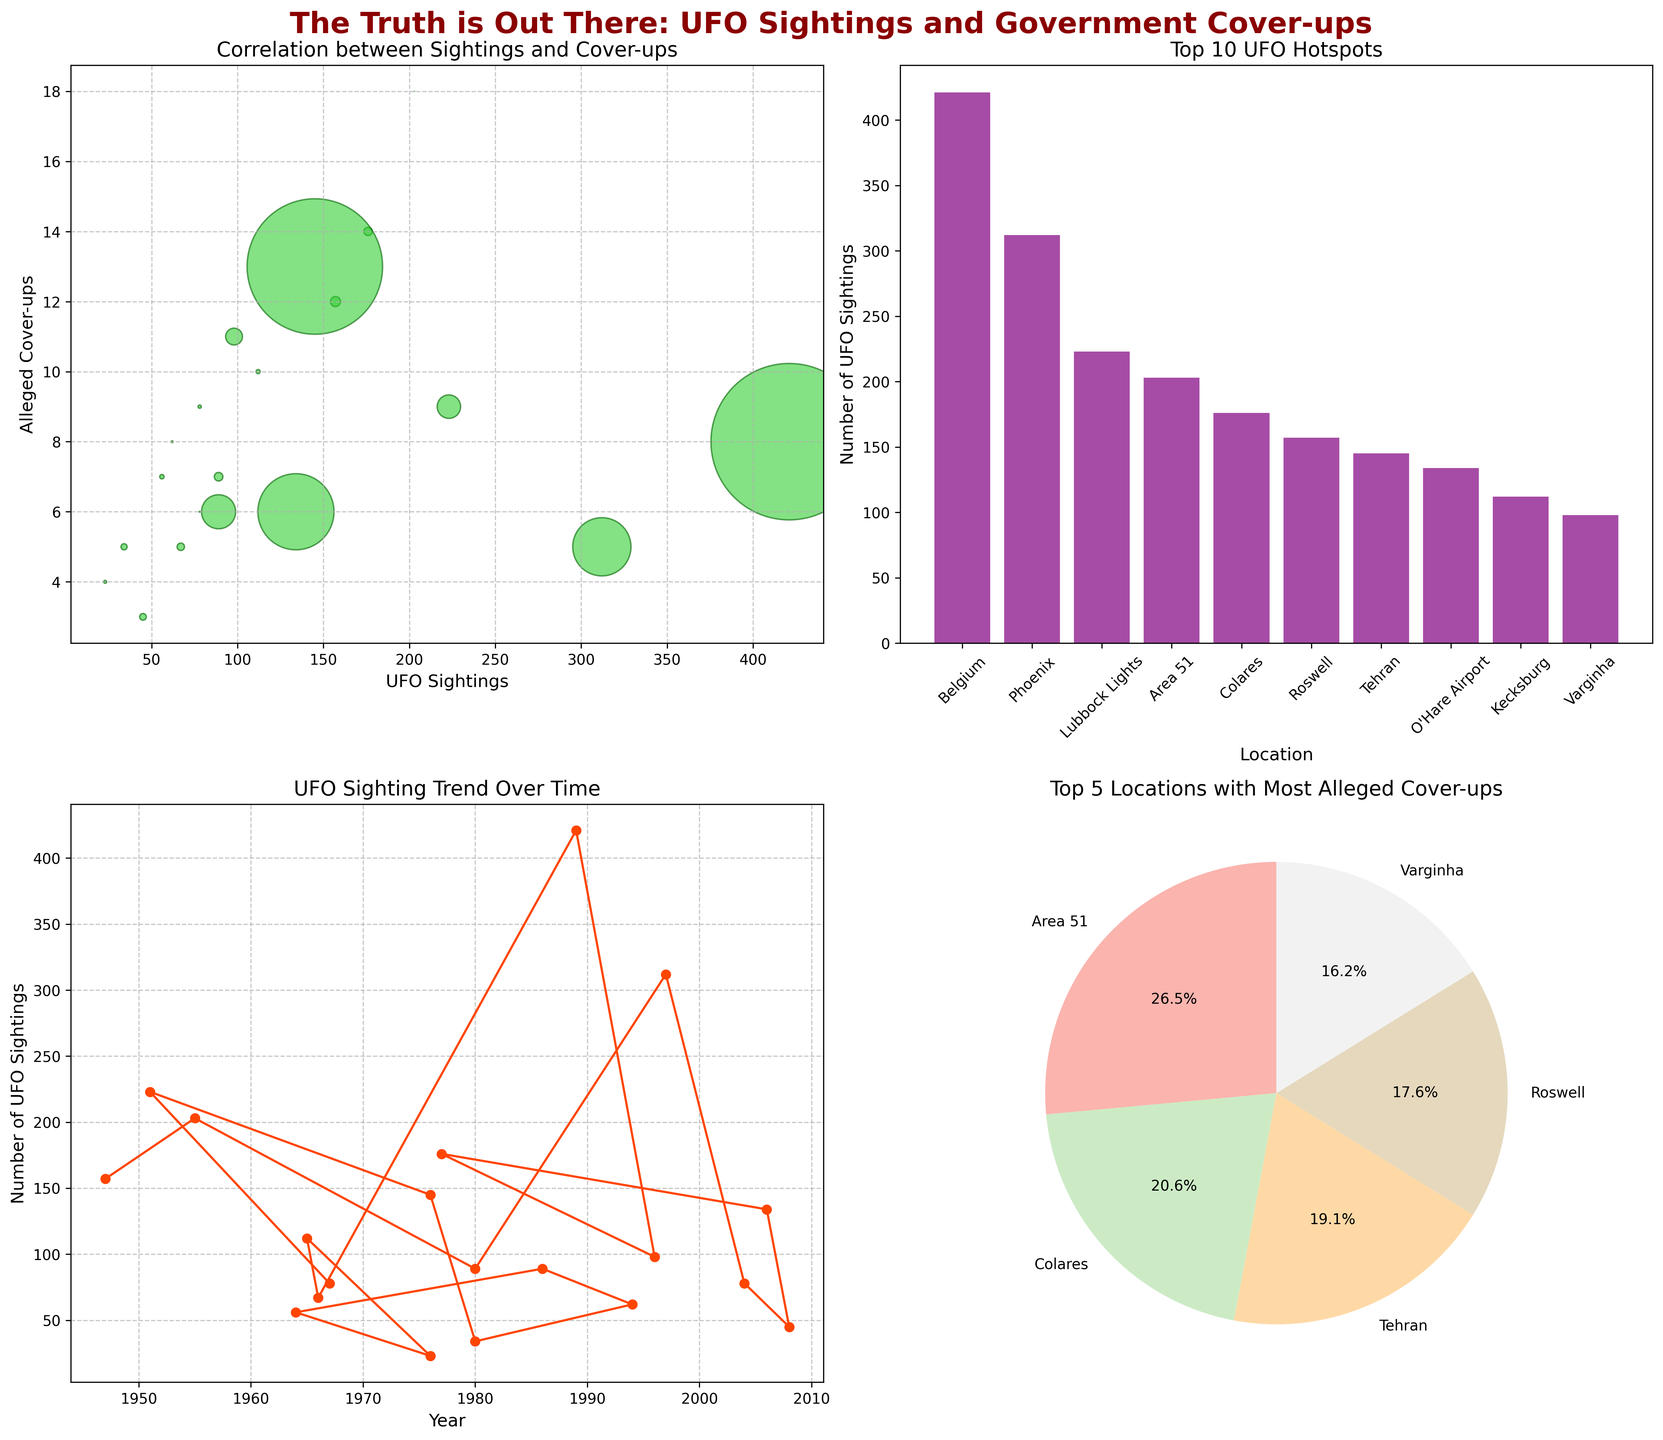What's the main observation from the scatter plot on UFO Sightings vs. Alleged Cover-ups? To observe the main trend, note the distribution and the relationship between UFO Sightings and Alleged Cover-ups. The scatter plot shows that locations with more UFO sightings tend to have more alleged government cover-ups. The larger bubbles (indicating larger population) are also prevalent among higher UFO sighting counts.
Answer: More sightings correlate with more cover-ups Which location has the highest number of UFO sightings and how many? From the bar plot of the top 10 locations by UFO sightings, it is evident that Belgium has the highest number with 421 sightings.
Answer: Belgium, 421 What is the overall trend in UFO sightings over time? By examining the line plot showing UFO sightings over the years, we see that there is no consistent upward or downward trend; sightings fluctuate significantly across different years, with some peaks and troughs.
Answer: Fluctuating trend Compare the locations with the most and least alleged cover-ups from the pie chart. The pie chart of the top 5 locations for alleged cover-ups shows that Area 51 has the most alleged cover-ups with 18, while Roswell has the least among the top 5 with 12.
Answer: Area 51 has the most (18), Roswell the least (12) How do the UFO sightings in Roswell compare to those in Phoenix? From the bar plot, Roswell has 157 UFO sightings, while Phoenix has 312. Therefore, sightings in Phoenix are nearly double those in Roswell.
Answer: Phoenix has nearly double Determine the sum of UFO sightings for the locations with the top 5 alleged cover-ups. The top 5 locations with the most alleged cover-ups as per the pie chart are Area 51, Colares, Tehran, Roswell, and Varginha. Their respective UFO sightings are 203, 176, 145, 157, and 98. Summing these up: 203 + 176 + 145 + 157 + 98 = 779.
Answer: 779 Which year had the highest number of UFO sightings, and what was the number? Observing the line plot, the year with the highest peak in UFO sightings is 1989, with Belgium reporting 421 sightings.
Answer: 1989, 421 What fraction of all alleged cover-ups do the top 5 locations account for? Add the alleged cover-ups for the top 5 locations (Area 51: 18, Colares: 14, Tehran: 13, Roswell: 12, Varginha: 11), which is 68. Summing all alleged cover-ups from the data (12 + 18 + 7 + 5 + 9 + 3 + 6 + 14 + 11 + 8 + 5 + 10 + 4 + 7 + 6 + 8 + 5 + 13 + 9 + 6) gives 167. The fraction is 68/167.
Answer: 68/167 